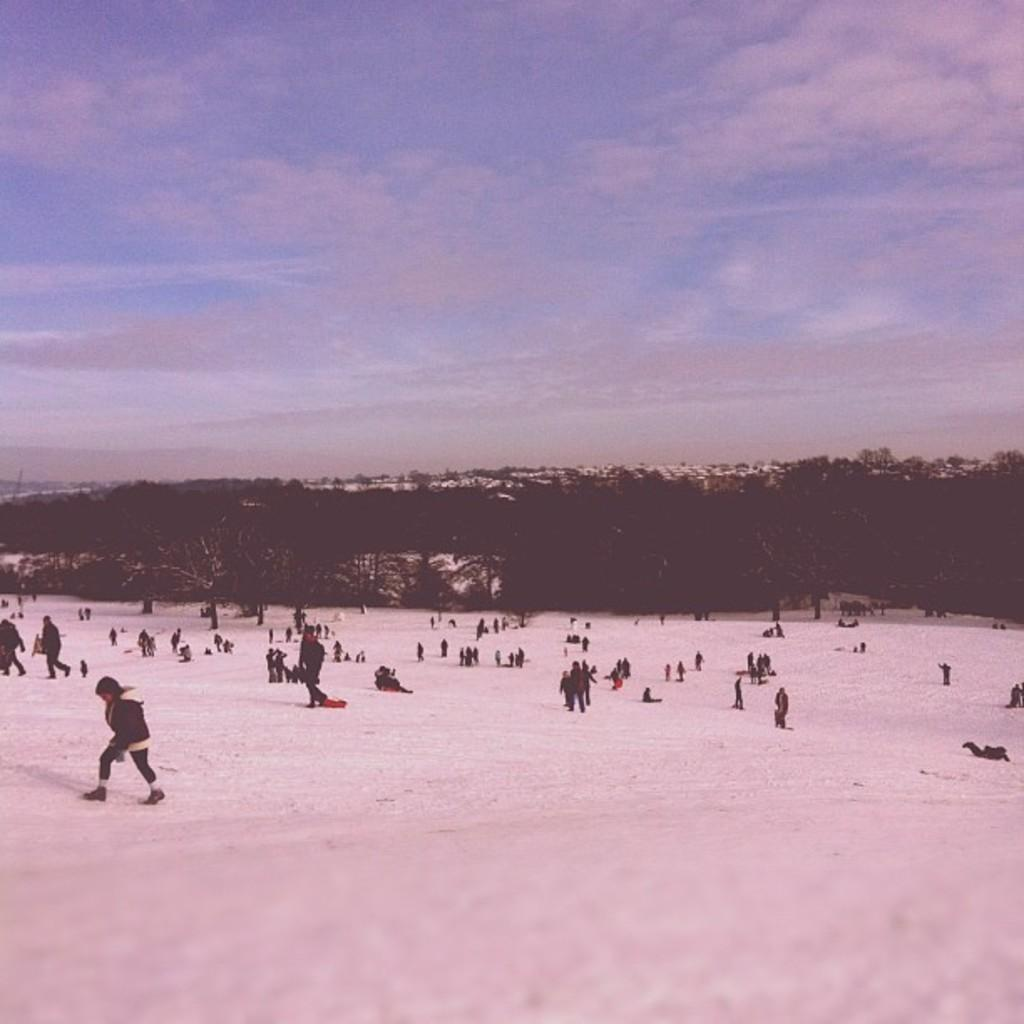How many people are in the image? There are people in the image, but the exact number is not specified. What are the people doing in the image? Some people are standing, while others are sitting. What is the surface the people are on? The people are on snow. What type of vegetation can be seen in the image? There are trees and plants in the image. Can you see any lizards crawling on the snow in the image? There are no lizards present in the image. What type of pear is being held by one of the people in the image? There is no pear visible in the image. 